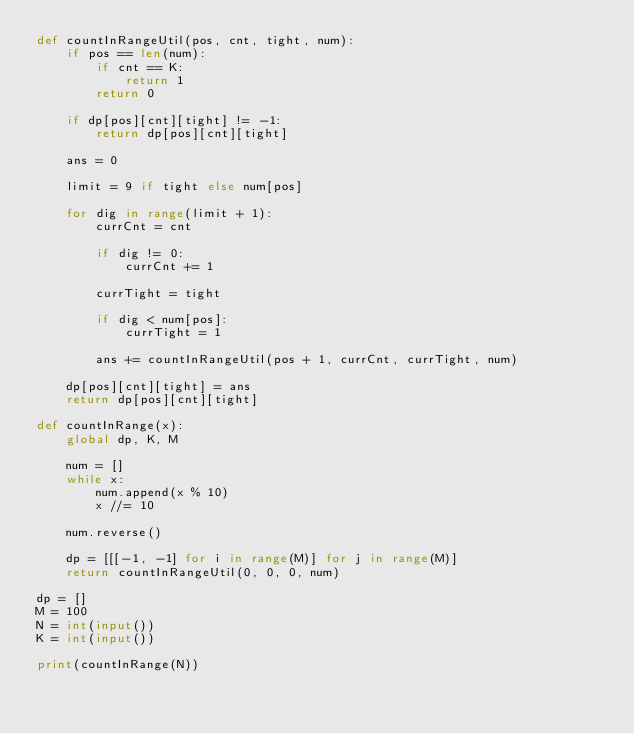<code> <loc_0><loc_0><loc_500><loc_500><_Python_>def countInRangeUtil(pos, cnt, tight, num):   
    if pos == len(num):   
        if cnt == K: 
            return 1
        return 0
  
    if dp[pos][cnt][tight] != -1: 
        return dp[pos][cnt][tight] 
  
    ans = 0
  
    limit = 9 if tight else num[pos] 
  
    for dig in range(limit + 1): 
        currCnt = cnt 
  
        if dig != 0: 
            currCnt += 1
  
        currTight = tight 
  
        if dig < num[pos]: 
            currTight = 1
  
        ans += countInRangeUtil(pos + 1, currCnt, currTight, num) 
  
    dp[pos][cnt][tight] = ans 
    return dp[pos][cnt][tight] 
  
def countInRange(x): 
    global dp, K, M 
  
    num = [] 
    while x: 
        num.append(x % 10) 
        x //= 10
  
    num.reverse() 
  
    dp = [[[-1, -1] for i in range(M)] for j in range(M)] 
    return countInRangeUtil(0, 0, 0, num) 
  
dp = [] 
M = 100
N = int(input())
K = int(input())

print(countInRange(N)) 
</code> 